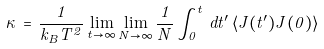<formula> <loc_0><loc_0><loc_500><loc_500>\kappa \, = \, \frac { 1 } { k _ { B } T ^ { 2 } } \lim _ { t \to \infty } \lim _ { N \to \infty } \frac { 1 } { N } \int _ { 0 } ^ { t } \, d t ^ { \prime } \, \langle J ( t ^ { \prime } ) J ( 0 ) \rangle</formula> 